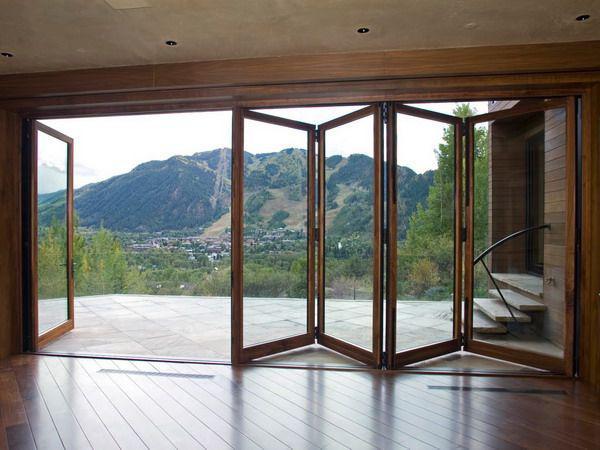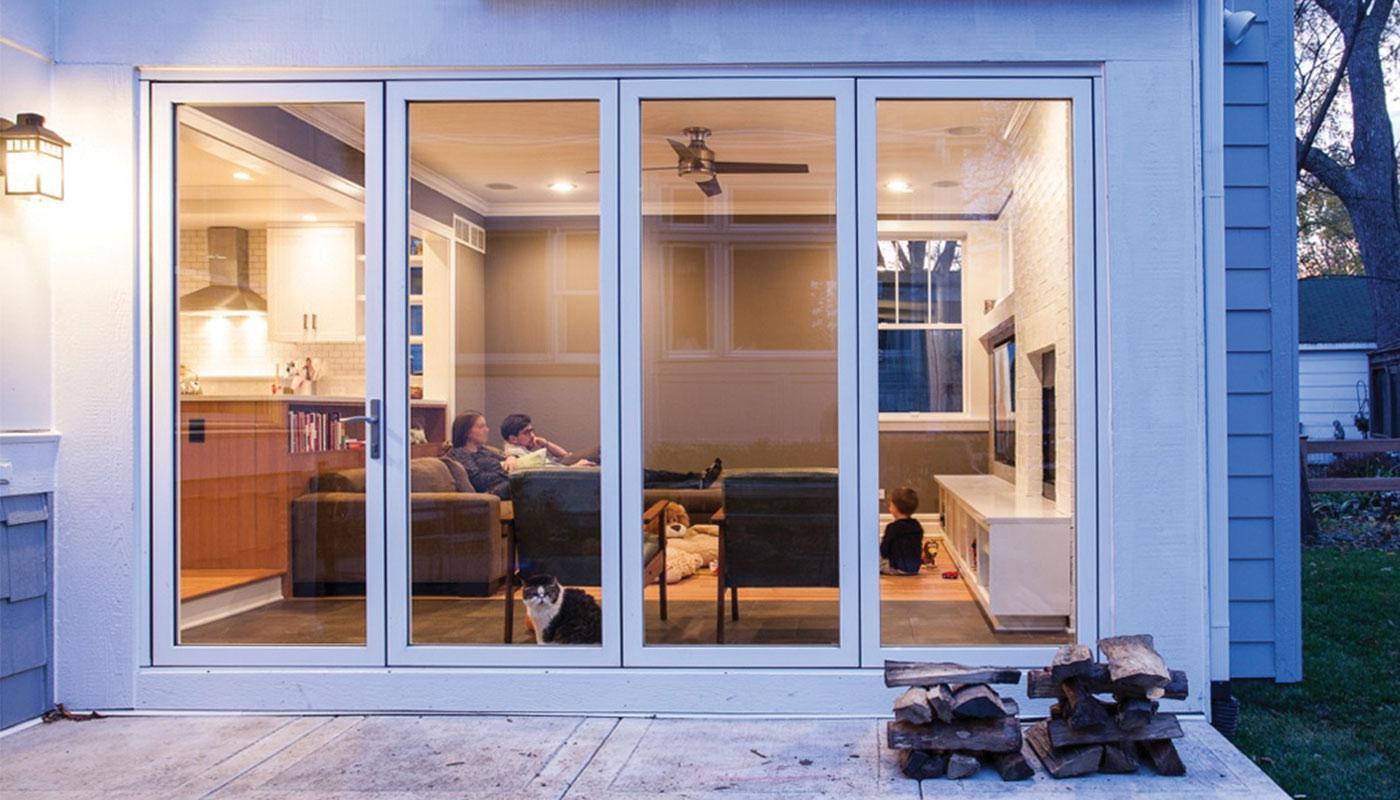The first image is the image on the left, the second image is the image on the right. Considering the images on both sides, is "In at least one image there is a six parily open glass door panels attached to each other." valid? Answer yes or no. No. The first image is the image on the left, the second image is the image on the right. Analyze the images presented: Is the assertion "An image shows a room with accordion-type sliding doors that are at least partly open, revealing a room-length view of natural scenery." valid? Answer yes or no. Yes. 